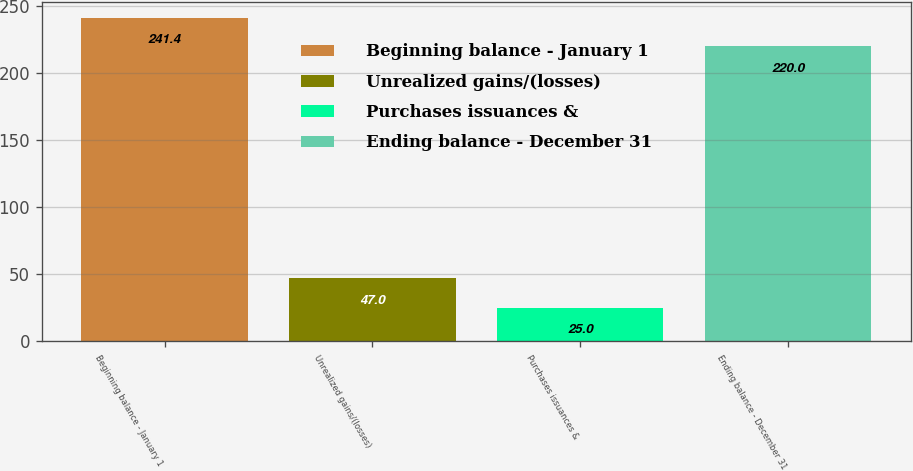Convert chart to OTSL. <chart><loc_0><loc_0><loc_500><loc_500><bar_chart><fcel>Beginning balance - January 1<fcel>Unrealized gains/(losses)<fcel>Purchases issuances &<fcel>Ending balance - December 31<nl><fcel>241.4<fcel>47<fcel>25<fcel>220<nl></chart> 